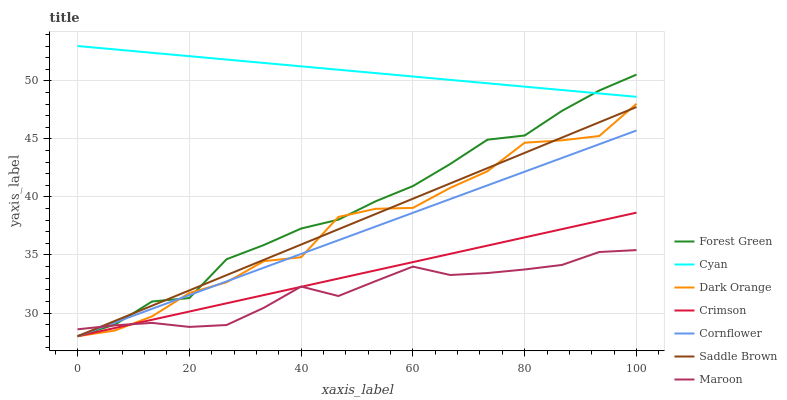Does Maroon have the minimum area under the curve?
Answer yes or no. Yes. Does Cyan have the maximum area under the curve?
Answer yes or no. Yes. Does Dark Orange have the minimum area under the curve?
Answer yes or no. No. Does Dark Orange have the maximum area under the curve?
Answer yes or no. No. Is Cyan the smoothest?
Answer yes or no. Yes. Is Dark Orange the roughest?
Answer yes or no. Yes. Is Maroon the smoothest?
Answer yes or no. No. Is Maroon the roughest?
Answer yes or no. No. Does Cornflower have the lowest value?
Answer yes or no. Yes. Does Maroon have the lowest value?
Answer yes or no. No. Does Cyan have the highest value?
Answer yes or no. Yes. Does Dark Orange have the highest value?
Answer yes or no. No. Is Dark Orange less than Cyan?
Answer yes or no. Yes. Is Cyan greater than Crimson?
Answer yes or no. Yes. Does Maroon intersect Saddle Brown?
Answer yes or no. Yes. Is Maroon less than Saddle Brown?
Answer yes or no. No. Is Maroon greater than Saddle Brown?
Answer yes or no. No. Does Dark Orange intersect Cyan?
Answer yes or no. No. 